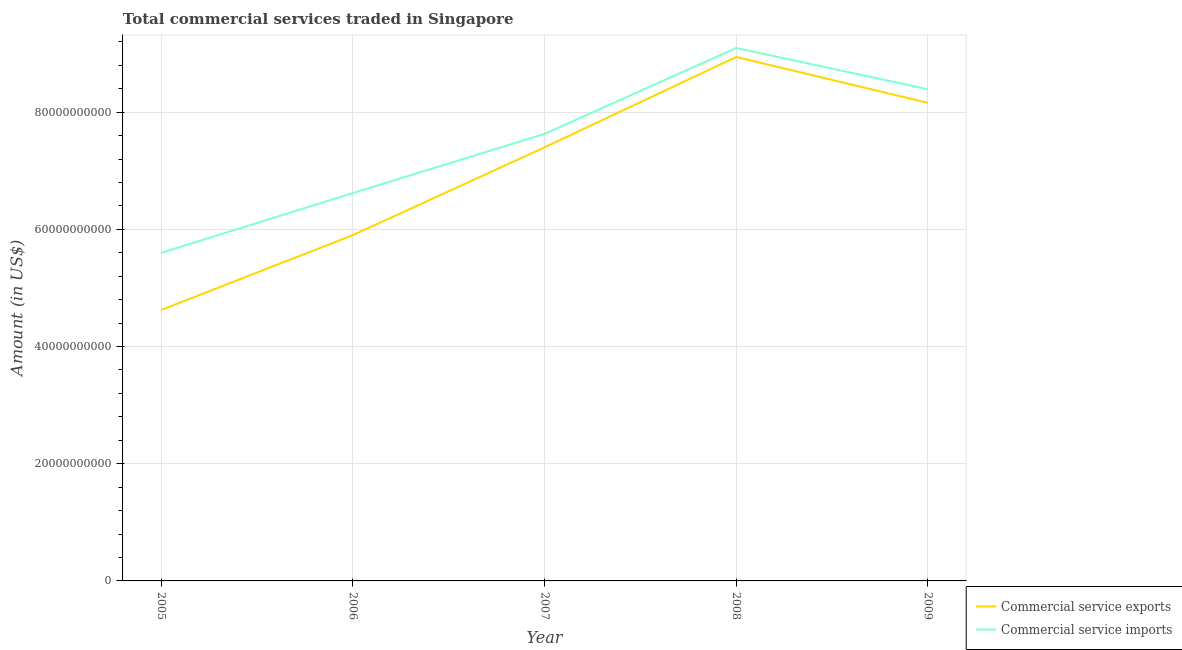Is the number of lines equal to the number of legend labels?
Offer a terse response. Yes. What is the amount of commercial service imports in 2009?
Your answer should be very brief. 8.39e+1. Across all years, what is the maximum amount of commercial service imports?
Your response must be concise. 9.10e+1. Across all years, what is the minimum amount of commercial service imports?
Give a very brief answer. 5.60e+1. In which year was the amount of commercial service exports maximum?
Give a very brief answer. 2008. What is the total amount of commercial service imports in the graph?
Your answer should be very brief. 3.73e+11. What is the difference between the amount of commercial service imports in 2006 and that in 2007?
Keep it short and to the point. -1.01e+1. What is the difference between the amount of commercial service imports in 2006 and the amount of commercial service exports in 2008?
Offer a terse response. -2.32e+1. What is the average amount of commercial service exports per year?
Make the answer very short. 7.01e+1. In the year 2007, what is the difference between the amount of commercial service exports and amount of commercial service imports?
Your response must be concise. -2.30e+09. In how many years, is the amount of commercial service imports greater than 4000000000 US$?
Your answer should be very brief. 5. What is the ratio of the amount of commercial service exports in 2005 to that in 2008?
Offer a terse response. 0.52. What is the difference between the highest and the second highest amount of commercial service exports?
Provide a short and direct response. 7.83e+09. What is the difference between the highest and the lowest amount of commercial service imports?
Provide a succinct answer. 3.50e+1. Does the amount of commercial service exports monotonically increase over the years?
Make the answer very short. No. Is the amount of commercial service imports strictly greater than the amount of commercial service exports over the years?
Give a very brief answer. Yes. Is the amount of commercial service exports strictly less than the amount of commercial service imports over the years?
Keep it short and to the point. Yes. How many lines are there?
Give a very brief answer. 2. How many years are there in the graph?
Offer a terse response. 5. What is the difference between two consecutive major ticks on the Y-axis?
Offer a terse response. 2.00e+1. Are the values on the major ticks of Y-axis written in scientific E-notation?
Your answer should be very brief. No. Does the graph contain grids?
Offer a very short reply. Yes. Where does the legend appear in the graph?
Provide a succinct answer. Bottom right. How are the legend labels stacked?
Provide a short and direct response. Vertical. What is the title of the graph?
Keep it short and to the point. Total commercial services traded in Singapore. Does "Import" appear as one of the legend labels in the graph?
Your response must be concise. No. What is the label or title of the Y-axis?
Your answer should be very brief. Amount (in US$). What is the Amount (in US$) of Commercial service exports in 2005?
Offer a very short reply. 4.62e+1. What is the Amount (in US$) of Commercial service imports in 2005?
Make the answer very short. 5.60e+1. What is the Amount (in US$) of Commercial service exports in 2006?
Your answer should be very brief. 5.90e+1. What is the Amount (in US$) of Commercial service imports in 2006?
Your answer should be compact. 6.62e+1. What is the Amount (in US$) in Commercial service exports in 2007?
Your answer should be compact. 7.40e+1. What is the Amount (in US$) in Commercial service imports in 2007?
Offer a terse response. 7.63e+1. What is the Amount (in US$) of Commercial service exports in 2008?
Your answer should be very brief. 8.94e+1. What is the Amount (in US$) in Commercial service imports in 2008?
Your answer should be compact. 9.10e+1. What is the Amount (in US$) in Commercial service exports in 2009?
Give a very brief answer. 8.16e+1. What is the Amount (in US$) in Commercial service imports in 2009?
Your answer should be compact. 8.39e+1. Across all years, what is the maximum Amount (in US$) of Commercial service exports?
Your answer should be very brief. 8.94e+1. Across all years, what is the maximum Amount (in US$) of Commercial service imports?
Your answer should be very brief. 9.10e+1. Across all years, what is the minimum Amount (in US$) in Commercial service exports?
Keep it short and to the point. 4.62e+1. Across all years, what is the minimum Amount (in US$) of Commercial service imports?
Make the answer very short. 5.60e+1. What is the total Amount (in US$) of Commercial service exports in the graph?
Keep it short and to the point. 3.50e+11. What is the total Amount (in US$) in Commercial service imports in the graph?
Keep it short and to the point. 3.73e+11. What is the difference between the Amount (in US$) of Commercial service exports in 2005 and that in 2006?
Your response must be concise. -1.28e+1. What is the difference between the Amount (in US$) in Commercial service imports in 2005 and that in 2006?
Keep it short and to the point. -1.02e+1. What is the difference between the Amount (in US$) of Commercial service exports in 2005 and that in 2007?
Provide a succinct answer. -2.78e+1. What is the difference between the Amount (in US$) in Commercial service imports in 2005 and that in 2007?
Your answer should be very brief. -2.03e+1. What is the difference between the Amount (in US$) in Commercial service exports in 2005 and that in 2008?
Make the answer very short. -4.32e+1. What is the difference between the Amount (in US$) of Commercial service imports in 2005 and that in 2008?
Give a very brief answer. -3.50e+1. What is the difference between the Amount (in US$) in Commercial service exports in 2005 and that in 2009?
Offer a terse response. -3.54e+1. What is the difference between the Amount (in US$) of Commercial service imports in 2005 and that in 2009?
Provide a short and direct response. -2.79e+1. What is the difference between the Amount (in US$) in Commercial service exports in 2006 and that in 2007?
Offer a very short reply. -1.50e+1. What is the difference between the Amount (in US$) of Commercial service imports in 2006 and that in 2007?
Make the answer very short. -1.01e+1. What is the difference between the Amount (in US$) of Commercial service exports in 2006 and that in 2008?
Your answer should be very brief. -3.04e+1. What is the difference between the Amount (in US$) in Commercial service imports in 2006 and that in 2008?
Offer a terse response. -2.48e+1. What is the difference between the Amount (in US$) of Commercial service exports in 2006 and that in 2009?
Your answer should be very brief. -2.26e+1. What is the difference between the Amount (in US$) of Commercial service imports in 2006 and that in 2009?
Provide a succinct answer. -1.77e+1. What is the difference between the Amount (in US$) in Commercial service exports in 2007 and that in 2008?
Make the answer very short. -1.54e+1. What is the difference between the Amount (in US$) of Commercial service imports in 2007 and that in 2008?
Offer a terse response. -1.47e+1. What is the difference between the Amount (in US$) in Commercial service exports in 2007 and that in 2009?
Provide a succinct answer. -7.60e+09. What is the difference between the Amount (in US$) in Commercial service imports in 2007 and that in 2009?
Your response must be concise. -7.62e+09. What is the difference between the Amount (in US$) in Commercial service exports in 2008 and that in 2009?
Your answer should be compact. 7.83e+09. What is the difference between the Amount (in US$) of Commercial service imports in 2008 and that in 2009?
Ensure brevity in your answer.  7.04e+09. What is the difference between the Amount (in US$) of Commercial service exports in 2005 and the Amount (in US$) of Commercial service imports in 2006?
Offer a very short reply. -2.00e+1. What is the difference between the Amount (in US$) in Commercial service exports in 2005 and the Amount (in US$) in Commercial service imports in 2007?
Make the answer very short. -3.01e+1. What is the difference between the Amount (in US$) in Commercial service exports in 2005 and the Amount (in US$) in Commercial service imports in 2008?
Your answer should be compact. -4.47e+1. What is the difference between the Amount (in US$) in Commercial service exports in 2005 and the Amount (in US$) in Commercial service imports in 2009?
Offer a terse response. -3.77e+1. What is the difference between the Amount (in US$) of Commercial service exports in 2006 and the Amount (in US$) of Commercial service imports in 2007?
Make the answer very short. -1.73e+1. What is the difference between the Amount (in US$) of Commercial service exports in 2006 and the Amount (in US$) of Commercial service imports in 2008?
Offer a terse response. -3.19e+1. What is the difference between the Amount (in US$) of Commercial service exports in 2006 and the Amount (in US$) of Commercial service imports in 2009?
Give a very brief answer. -2.49e+1. What is the difference between the Amount (in US$) of Commercial service exports in 2007 and the Amount (in US$) of Commercial service imports in 2008?
Ensure brevity in your answer.  -1.70e+1. What is the difference between the Amount (in US$) of Commercial service exports in 2007 and the Amount (in US$) of Commercial service imports in 2009?
Provide a succinct answer. -9.92e+09. What is the difference between the Amount (in US$) in Commercial service exports in 2008 and the Amount (in US$) in Commercial service imports in 2009?
Your response must be concise. 5.51e+09. What is the average Amount (in US$) of Commercial service exports per year?
Your answer should be compact. 7.01e+1. What is the average Amount (in US$) in Commercial service imports per year?
Give a very brief answer. 7.47e+1. In the year 2005, what is the difference between the Amount (in US$) of Commercial service exports and Amount (in US$) of Commercial service imports?
Your response must be concise. -9.74e+09. In the year 2006, what is the difference between the Amount (in US$) of Commercial service exports and Amount (in US$) of Commercial service imports?
Your answer should be very brief. -7.18e+09. In the year 2007, what is the difference between the Amount (in US$) of Commercial service exports and Amount (in US$) of Commercial service imports?
Give a very brief answer. -2.30e+09. In the year 2008, what is the difference between the Amount (in US$) in Commercial service exports and Amount (in US$) in Commercial service imports?
Provide a short and direct response. -1.54e+09. In the year 2009, what is the difference between the Amount (in US$) in Commercial service exports and Amount (in US$) in Commercial service imports?
Your answer should be very brief. -2.32e+09. What is the ratio of the Amount (in US$) in Commercial service exports in 2005 to that in 2006?
Offer a very short reply. 0.78. What is the ratio of the Amount (in US$) of Commercial service imports in 2005 to that in 2006?
Keep it short and to the point. 0.85. What is the ratio of the Amount (in US$) of Commercial service imports in 2005 to that in 2007?
Offer a very short reply. 0.73. What is the ratio of the Amount (in US$) of Commercial service exports in 2005 to that in 2008?
Make the answer very short. 0.52. What is the ratio of the Amount (in US$) of Commercial service imports in 2005 to that in 2008?
Give a very brief answer. 0.62. What is the ratio of the Amount (in US$) in Commercial service exports in 2005 to that in 2009?
Offer a terse response. 0.57. What is the ratio of the Amount (in US$) in Commercial service imports in 2005 to that in 2009?
Provide a short and direct response. 0.67. What is the ratio of the Amount (in US$) of Commercial service exports in 2006 to that in 2007?
Give a very brief answer. 0.8. What is the ratio of the Amount (in US$) of Commercial service imports in 2006 to that in 2007?
Provide a short and direct response. 0.87. What is the ratio of the Amount (in US$) in Commercial service exports in 2006 to that in 2008?
Offer a terse response. 0.66. What is the ratio of the Amount (in US$) of Commercial service imports in 2006 to that in 2008?
Provide a succinct answer. 0.73. What is the ratio of the Amount (in US$) of Commercial service exports in 2006 to that in 2009?
Provide a short and direct response. 0.72. What is the ratio of the Amount (in US$) in Commercial service imports in 2006 to that in 2009?
Your answer should be very brief. 0.79. What is the ratio of the Amount (in US$) of Commercial service exports in 2007 to that in 2008?
Offer a terse response. 0.83. What is the ratio of the Amount (in US$) in Commercial service imports in 2007 to that in 2008?
Make the answer very short. 0.84. What is the ratio of the Amount (in US$) of Commercial service exports in 2007 to that in 2009?
Your answer should be very brief. 0.91. What is the ratio of the Amount (in US$) in Commercial service imports in 2007 to that in 2009?
Your answer should be compact. 0.91. What is the ratio of the Amount (in US$) in Commercial service exports in 2008 to that in 2009?
Provide a short and direct response. 1.1. What is the ratio of the Amount (in US$) of Commercial service imports in 2008 to that in 2009?
Ensure brevity in your answer.  1.08. What is the difference between the highest and the second highest Amount (in US$) of Commercial service exports?
Make the answer very short. 7.83e+09. What is the difference between the highest and the second highest Amount (in US$) of Commercial service imports?
Make the answer very short. 7.04e+09. What is the difference between the highest and the lowest Amount (in US$) of Commercial service exports?
Provide a succinct answer. 4.32e+1. What is the difference between the highest and the lowest Amount (in US$) in Commercial service imports?
Keep it short and to the point. 3.50e+1. 